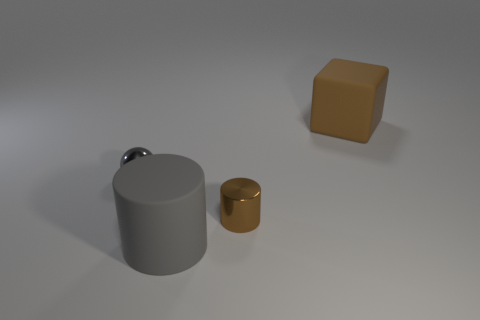There is a matte object behind the tiny gray object; does it have the same shape as the small gray metallic thing?
Give a very brief answer. No. What number of objects are both to the right of the gray cylinder and behind the small brown metal cylinder?
Your answer should be compact. 1. The large matte object that is on the left side of the matte cube has what shape?
Your response must be concise. Cylinder. How many large gray objects have the same material as the tiny gray object?
Your response must be concise. 0. There is a tiny brown metal thing; is its shape the same as the big thing that is in front of the tiny gray metallic object?
Your answer should be compact. Yes. Is there a tiny sphere that is to the right of the matte object that is in front of the large matte object that is right of the tiny cylinder?
Provide a succinct answer. No. There is a rubber thing in front of the sphere; what is its size?
Your answer should be very brief. Large. There is a ball that is the same size as the brown cylinder; what is its material?
Give a very brief answer. Metal. Is the shape of the tiny gray object the same as the big brown rubber thing?
Offer a very short reply. No. How many things are either large red shiny spheres or things behind the large gray matte thing?
Your answer should be compact. 3. 